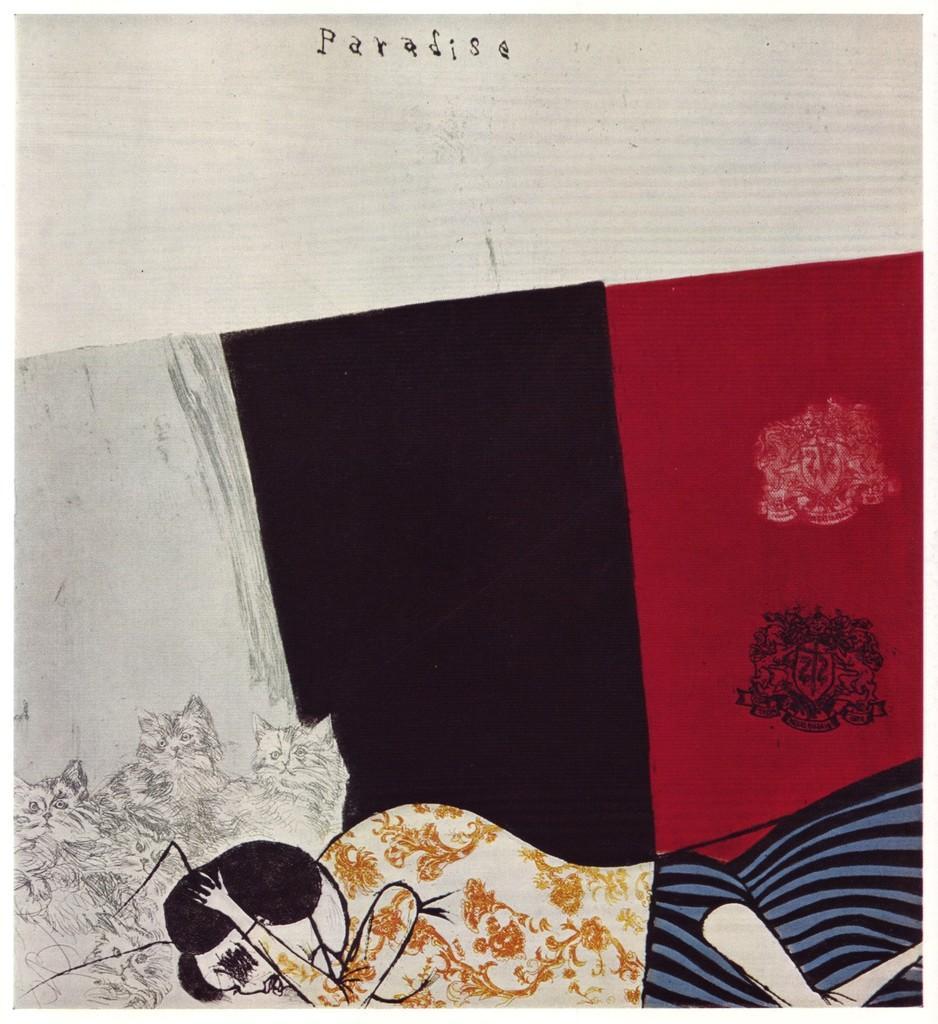How would you summarize this image in a sentence or two? This looks like a pencil art of the woman and the cats. I can see the design. These are the letters in the image. 